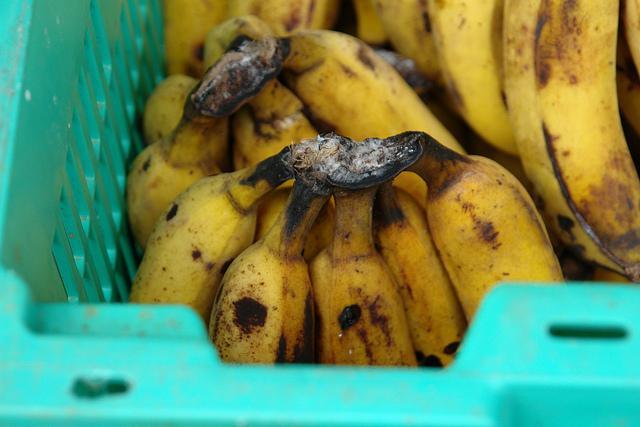What two brands of bananas are shown?
Be succinct. No brand. What time of day was the picture taken?
Concise answer only. Day. Are these bananas ripe?
Write a very short answer. Yes. What is the bananas sitting in?
Be succinct. Basket. 